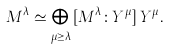Convert formula to latex. <formula><loc_0><loc_0><loc_500><loc_500>M ^ { \lambda } \simeq \bigoplus _ { \mu \geq \lambda } \, [ M ^ { \lambda } \colon Y ^ { \mu } ] \, Y ^ { \mu } .</formula> 